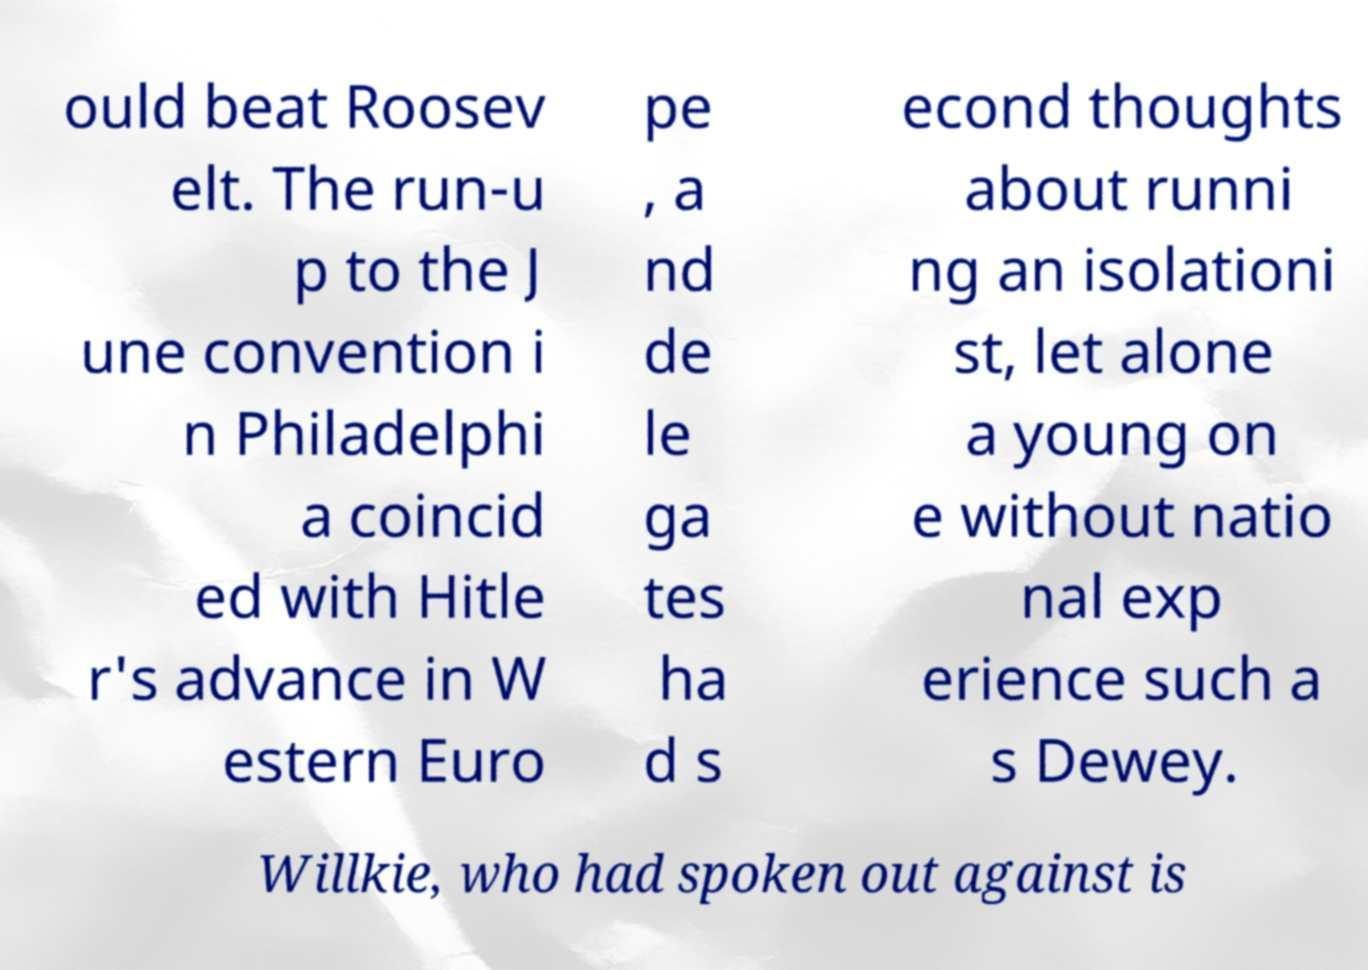What messages or text are displayed in this image? I need them in a readable, typed format. ould beat Roosev elt. The run-u p to the J une convention i n Philadelphi a coincid ed with Hitle r's advance in W estern Euro pe , a nd de le ga tes ha d s econd thoughts about runni ng an isolationi st, let alone a young on e without natio nal exp erience such a s Dewey. Willkie, who had spoken out against is 